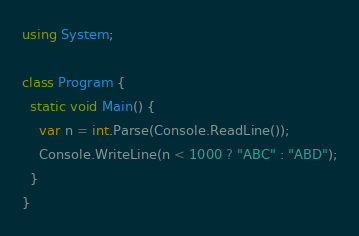<code> <loc_0><loc_0><loc_500><loc_500><_C#_>using System;

class Program {
  static void Main() {
    var n = int.Parse(Console.ReadLine());
    Console.WriteLine(n < 1000 ? "ABC" : "ABD");
  }
}</code> 